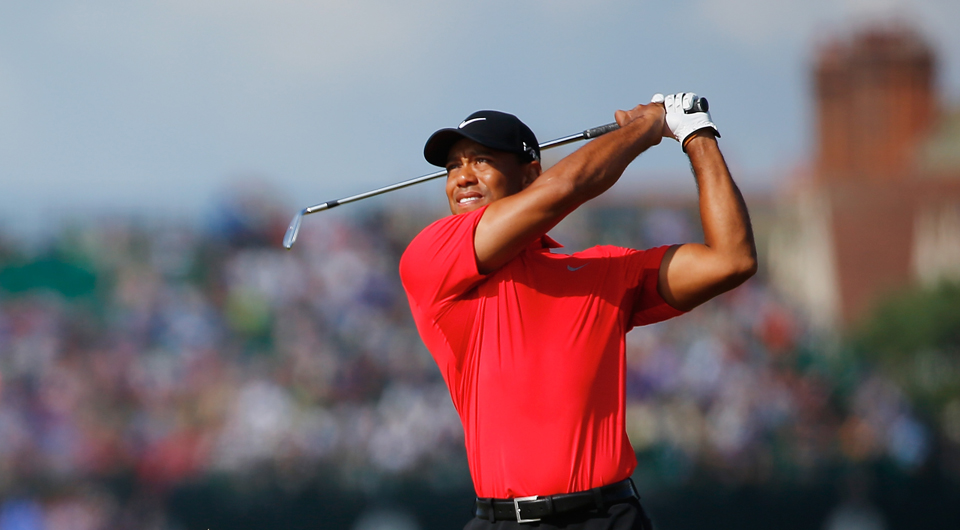What kind of preparation do you think the golfer has undergone to perform at such a high level? The golfer likely has undergone extensive preparation to perform at such a high level. This includes rigorous physical training to maintain strength, flexibility, and stamina. Additionally, the golfer would have spent countless hours practicing their swing, honing techniques, and strategizing for different courses. Mental preparation is equally important, involving focus, visualization, and perhaps even working with sports psychologists to ensure peak performance during tournaments. 